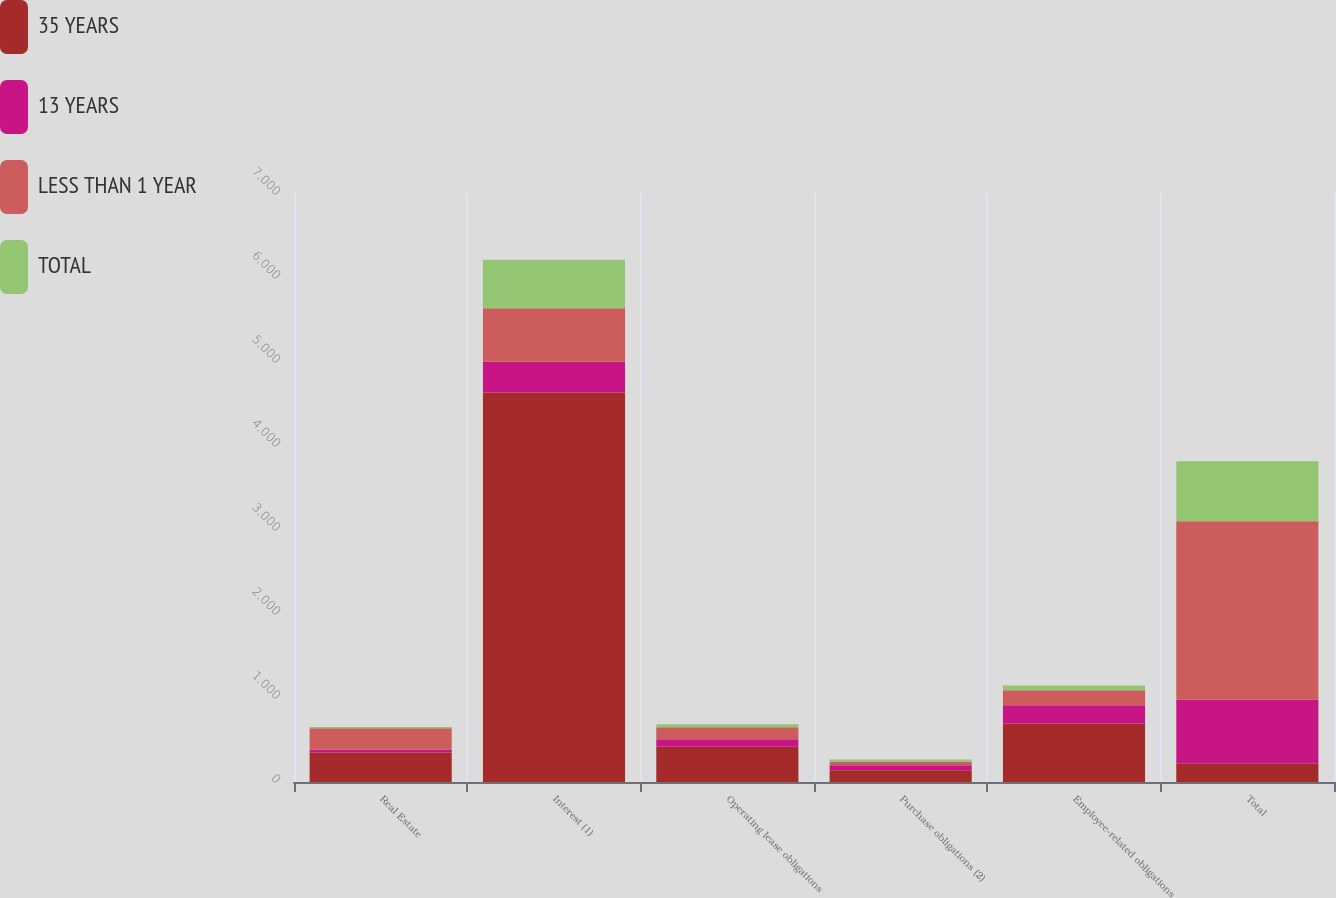<chart> <loc_0><loc_0><loc_500><loc_500><stacked_bar_chart><ecel><fcel>Real Estate<fcel>Interest (1)<fcel>Operating lease obligations<fcel>Purchase obligations (2)<fcel>Employee-related obligations<fcel>Total<nl><fcel>35 YEARS<fcel>350<fcel>4636<fcel>421<fcel>140<fcel>697<fcel>216<nl><fcel>13 YEARS<fcel>33<fcel>366<fcel>88<fcel>60<fcel>216<fcel>763<nl><fcel>LESS THAN 1 YEAR<fcel>257<fcel>638<fcel>142<fcel>41<fcel>179<fcel>2126<nl><fcel>TOTAL<fcel>15<fcel>576<fcel>37<fcel>27<fcel>58<fcel>713<nl></chart> 